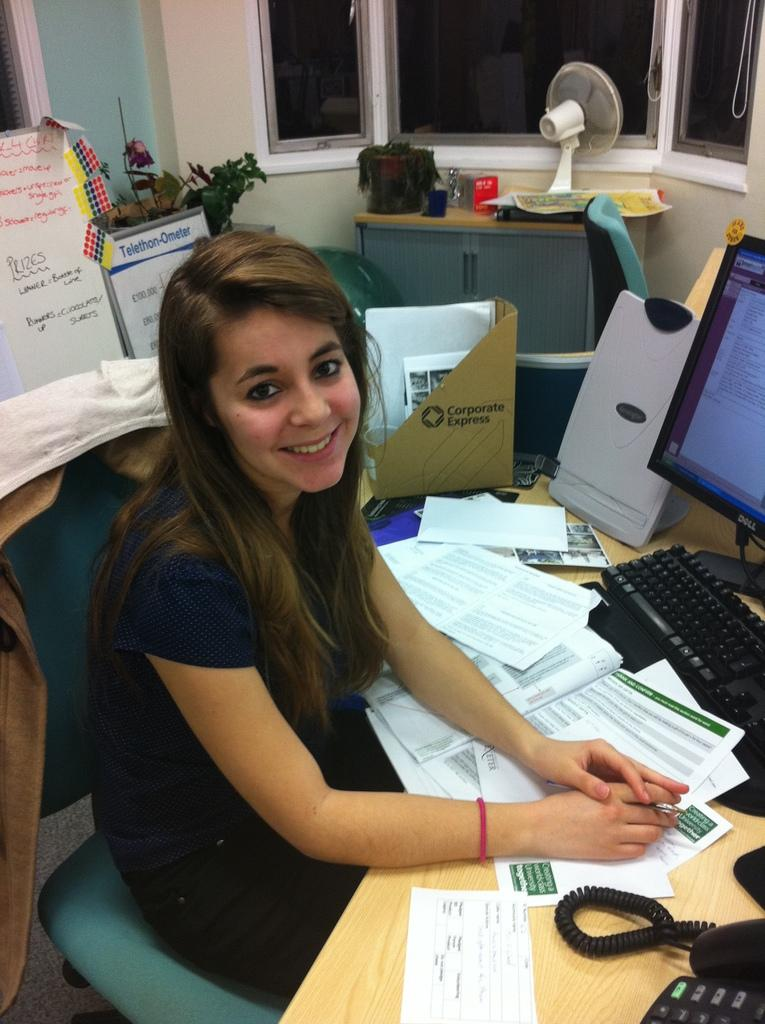<image>
Summarize the visual content of the image. A woman at a messy desk with a box that says Corporate Express behind her. 